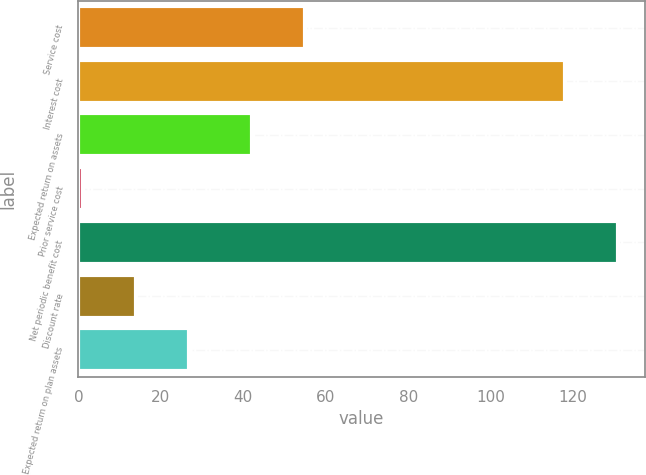Convert chart. <chart><loc_0><loc_0><loc_500><loc_500><bar_chart><fcel>Service cost<fcel>Interest cost<fcel>Expected return on assets<fcel>Prior service cost<fcel>Net periodic benefit cost<fcel>Discount rate<fcel>Expected return on plan assets<nl><fcel>55<fcel>118<fcel>42<fcel>1<fcel>130.9<fcel>13.9<fcel>26.8<nl></chart> 